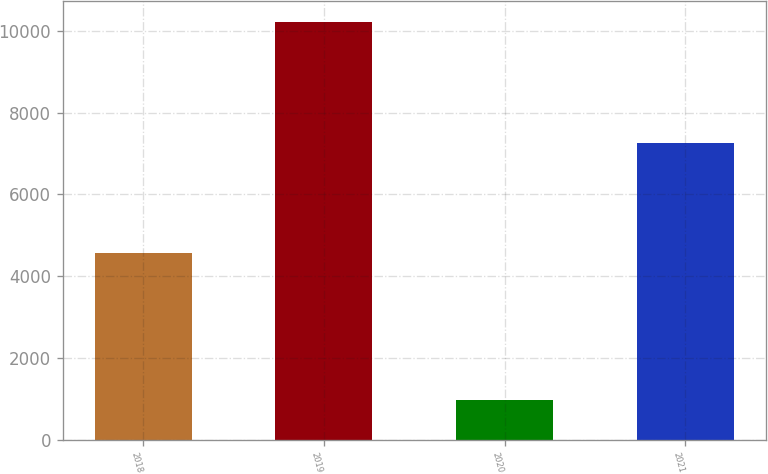<chart> <loc_0><loc_0><loc_500><loc_500><bar_chart><fcel>2018<fcel>2019<fcel>2020<fcel>2021<nl><fcel>4563<fcel>10220<fcel>959<fcel>7249<nl></chart> 